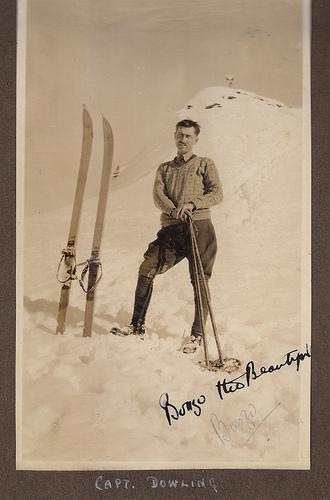Describe the man's facial features in the photo. The man has a mustache over his open mouth and is wearing a sweater, shirt, and tie. Can you count the number of ski poles in the image? Provide the answer in a single word. Four Identify the main activity taking place in the image. A skier is posing for a photo while standing in the snow with ski poles in his hands. What are the two types of signatures mentioned in the image? Preprinted and handsigned, and person's signature in gray writing. What is the landscape behind the skier showing? Mountain top with a steep slope. What type of design is on the man's sweater? Squares within squares design. Mention three objects that can be found in the snow. Snowy ground, skis standing vertically, and shadow behind skis. What kind of writing can be found under the photo? White writing. What is the dominant color theme of the photograph? Sepia-toned Explain the general sentiment or mood of the image. A nostalgic or vintage mood due to the sepia color and winter sports theme. Is the person wearing a hat in the image? There is no mention of a hat or headwear in any of the given object details, making this instruction misleading. Is there a cabin or building in the image? The given object details do not describe any cabin, building, or architecture, making this instruction irrelevant and misleading based on the available information. What visual evidence can you see regarding the ground in the image? White snow on the ground What is the overall color theme of the photograph?  An old sephia colored photograph Describe the features of the man's face in the photograph. Mustache over open mouth Are there any visible trees in the picture? The given object details don't describe any trees or tree-like features, so this instruction is not relevant to the existing objects. Please select the equipment being utilised by the man. Options: A) Skiis B) Snowboard C) Sled A) Skiis Identify the clothing items and patterns that the man is wearing. Sweater design of squares within squares, shirt and tie under sweater Can you find a pair of sunglasses on the man's face? No, it's not mentioned in the image. Read and identify the text found around the photo. preprinted and handsigned signatures, white writing under the photo, persons signature in gray writing What is the background of the image? Is art hill visible? Mountain top with steep slope above skier, top of the ski hill in the background Identify and describe the person's posture and hand position. One hand over the other, skier holding ski poles to the side 